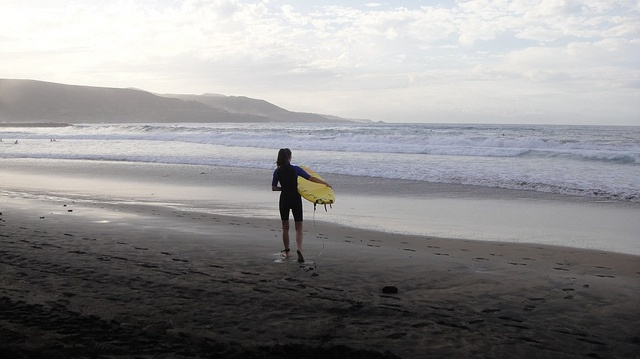Describe the objects in this image and their specific colors. I can see people in white, black, gray, darkgray, and tan tones and surfboard in ivory, olive, darkgray, and gray tones in this image. 